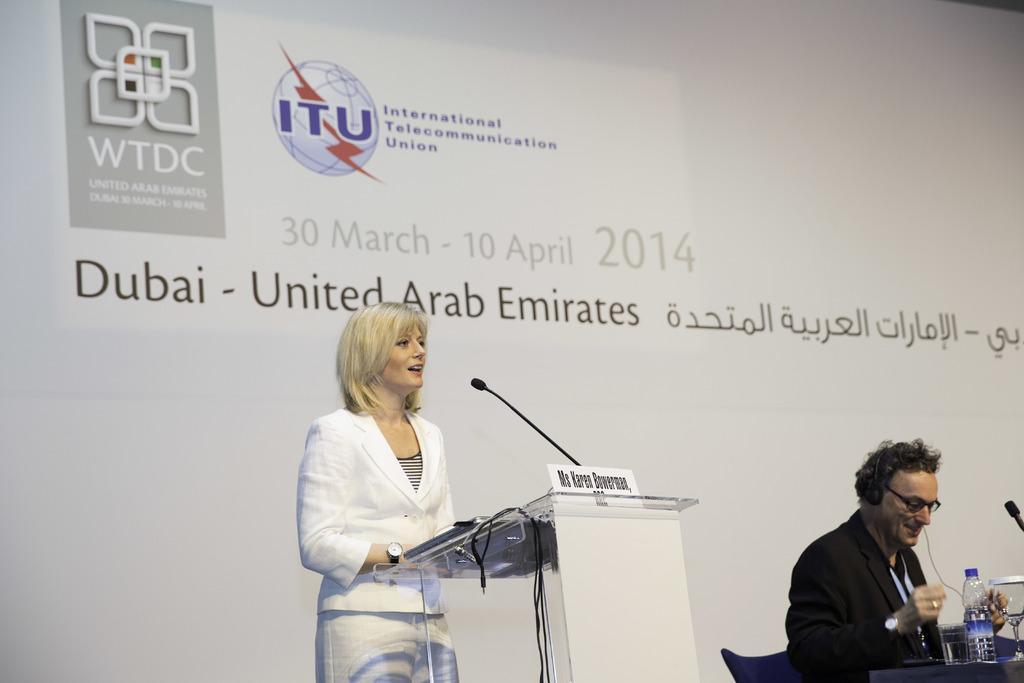Can you describe this image briefly? In this picture I can see a woman standing near the podium, there is a nameplate and a mike on the podium, there is a man sitting on the chair, there are glasses, bottle and there is an another mike on the table, and in the background there is a board. 